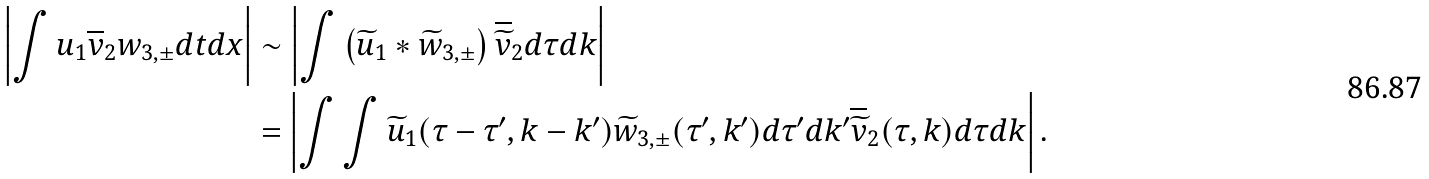<formula> <loc_0><loc_0><loc_500><loc_500>\left | \int u _ { 1 } \overline { v } _ { 2 } w _ { 3 , \pm } d t d x \right | & \sim \left | \int \left ( \widetilde { u } _ { 1 } * \widetilde { w } _ { 3 , \pm } \right ) \overline { \widetilde { v } } _ { 2 } d \tau d k \right | \\ & = \left | \int \int \widetilde { u } _ { 1 } ( \tau - \tau ^ { \prime } , k - k ^ { \prime } ) \widetilde { w } _ { 3 , \pm } ( \tau ^ { \prime } , k ^ { \prime } ) d \tau ^ { \prime } d k ^ { \prime } \overline { \widetilde { v } } _ { 2 } ( \tau , k ) d \tau d k \right | .</formula> 